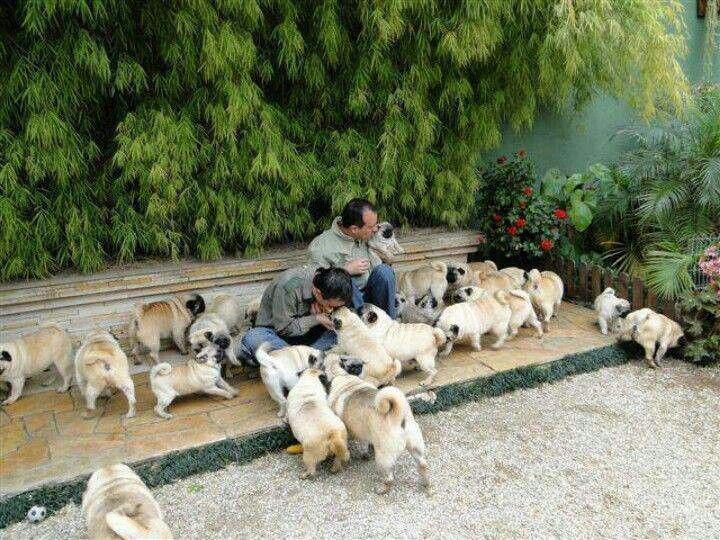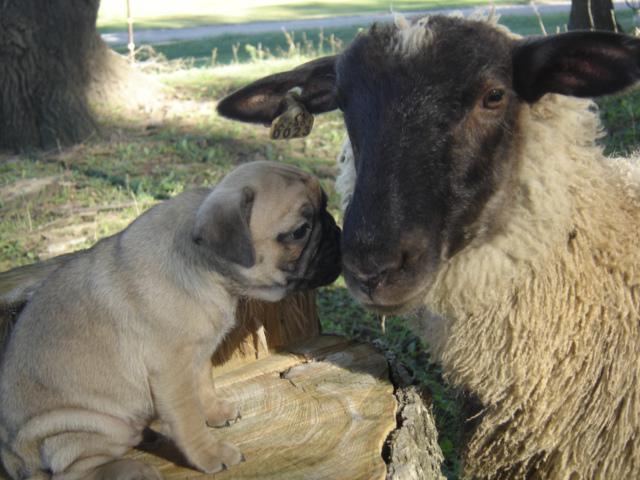The first image is the image on the left, the second image is the image on the right. Considering the images on both sides, is "At least one of the images contains only a single pug." valid? Answer yes or no. Yes. The first image is the image on the left, the second image is the image on the right. For the images shown, is this caption "In at least one image, at least one pug is wearing clothes." true? Answer yes or no. No. 